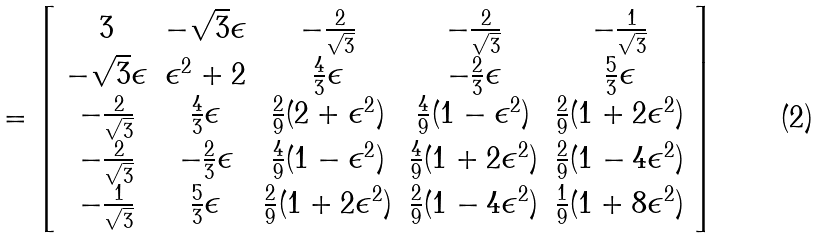<formula> <loc_0><loc_0><loc_500><loc_500>= \left [ \begin{array} { c c c c c } 3 & - \sqrt { 3 } \epsilon & - \frac { 2 } { \sqrt { 3 } } & - \frac { 2 } { \sqrt { 3 } } & - \frac { 1 } { \sqrt { 3 } } \\ - \sqrt { 3 } \epsilon & \epsilon ^ { 2 } + 2 & \frac { 4 } { 3 } \epsilon & - \frac { 2 } { 3 } \epsilon & \frac { 5 } { 3 } \epsilon \\ - \frac { 2 } { \sqrt { 3 } } & \frac { 4 } { 3 } \epsilon & \frac { 2 } { 9 } ( 2 + \epsilon ^ { 2 } ) & \frac { 4 } { 9 } ( 1 - \epsilon ^ { 2 } ) & \frac { 2 } { 9 } ( 1 + 2 \epsilon ^ { 2 } ) \\ - \frac { 2 } { \sqrt { 3 } } & - \frac { 2 } { 3 } \epsilon & \frac { 4 } { 9 } ( 1 - \epsilon ^ { 2 } ) & \frac { 4 } { 9 } ( 1 + 2 \epsilon ^ { 2 } ) & \frac { 2 } { 9 } ( 1 - 4 \epsilon ^ { 2 } ) \\ - \frac { 1 } { \sqrt { 3 } } & \frac { 5 } { 3 } \epsilon & \frac { 2 } { 9 } ( 1 + 2 \epsilon ^ { 2 } ) & \frac { 2 } { 9 } ( 1 - 4 \epsilon ^ { 2 } ) & \frac { 1 } { 9 } ( 1 + 8 \epsilon ^ { 2 } ) \end{array} \right ]</formula> 